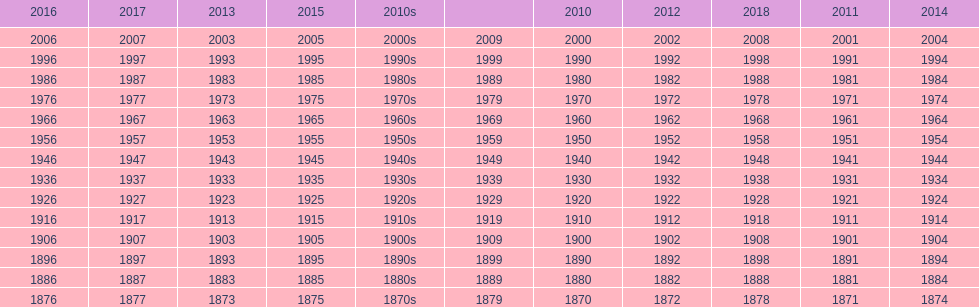Could you parse the entire table as a dict? {'header': ['2016', '2017', '2013', '2015', '2010s', '', '2010', '2012', '2018', '2011', '2014'], 'rows': [['2006', '2007', '2003', '2005', '2000s', '2009', '2000', '2002', '2008', '2001', '2004'], ['1996', '1997', '1993', '1995', '1990s', '1999', '1990', '1992', '1998', '1991', '1994'], ['1986', '1987', '1983', '1985', '1980s', '1989', '1980', '1982', '1988', '1981', '1984'], ['1976', '1977', '1973', '1975', '1970s', '1979', '1970', '1972', '1978', '1971', '1974'], ['1966', '1967', '1963', '1965', '1960s', '1969', '1960', '1962', '1968', '1961', '1964'], ['1956', '1957', '1953', '1955', '1950s', '1959', '1950', '1952', '1958', '1951', '1954'], ['1946', '1947', '1943', '1945', '1940s', '1949', '1940', '1942', '1948', '1941', '1944'], ['1936', '1937', '1933', '1935', '1930s', '1939', '1930', '1932', '1938', '1931', '1934'], ['1926', '1927', '1923', '1925', '1920s', '1929', '1920', '1922', '1928', '1921', '1924'], ['1916', '1917', '1913', '1915', '1910s', '1919', '1910', '1912', '1918', '1911', '1914'], ['1906', '1907', '1903', '1905', '1900s', '1909', '1900', '1902', '1908', '1901', '1904'], ['1896', '1897', '1893', '1895', '1890s', '1899', '1890', '1892', '1898', '1891', '1894'], ['1886', '1887', '1883', '1885', '1880s', '1889', '1880', '1882', '1888', '1881', '1884'], ['1876', '1877', '1873', '1875', '1870s', '1879', '1870', '1872', '1878', '1871', '1874']]} What is the earliest year that a film was released? 1870. 